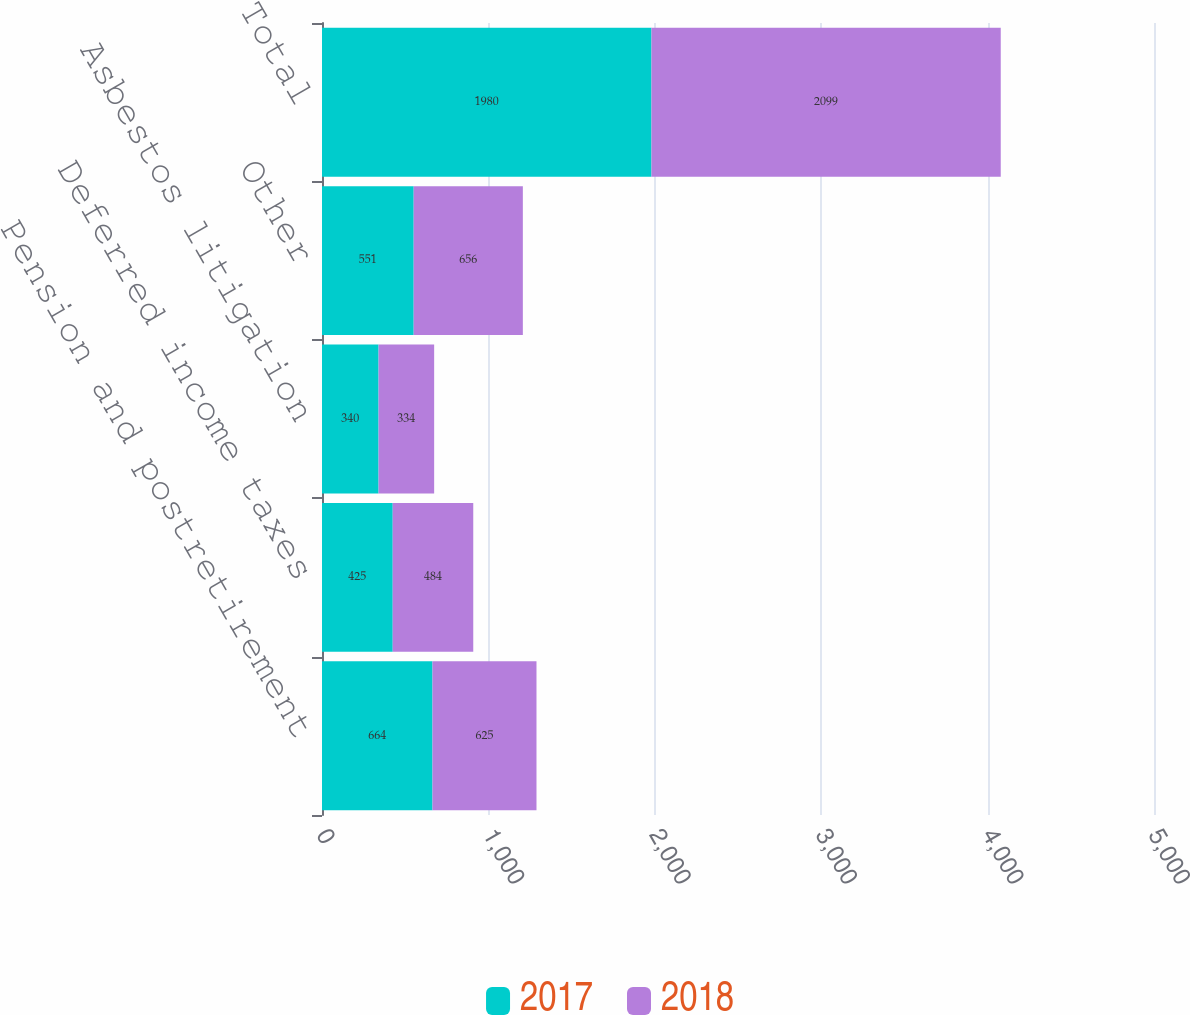<chart> <loc_0><loc_0><loc_500><loc_500><stacked_bar_chart><ecel><fcel>Pension and postretirement<fcel>Deferred income taxes<fcel>Asbestos litigation<fcel>Other<fcel>Total<nl><fcel>2017<fcel>664<fcel>425<fcel>340<fcel>551<fcel>1980<nl><fcel>2018<fcel>625<fcel>484<fcel>334<fcel>656<fcel>2099<nl></chart> 